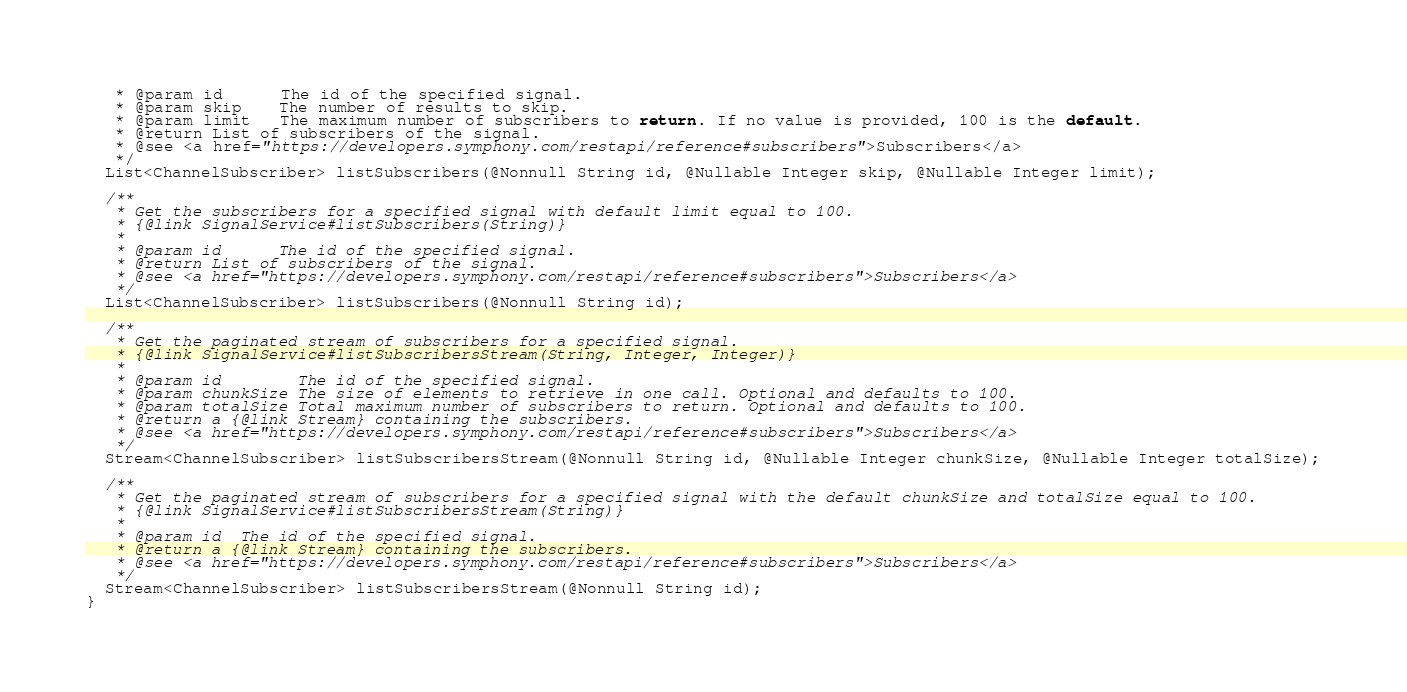<code> <loc_0><loc_0><loc_500><loc_500><_Java_>   * @param id      The id of the specified signal.
   * @param skip    The number of results to skip.
   * @param limit   The maximum number of subscribers to return. If no value is provided, 100 is the default.
   * @return List of subscribers of the signal.
   * @see <a href="https://developers.symphony.com/restapi/reference#subscribers">Subscribers</a>
   */
  List<ChannelSubscriber> listSubscribers(@Nonnull String id, @Nullable Integer skip, @Nullable Integer limit);

  /**
   * Get the subscribers for a specified signal with default limit equal to 100.
   * {@link SignalService#listSubscribers(String)}
   *
   * @param id      The id of the specified signal.
   * @return List of subscribers of the signal.
   * @see <a href="https://developers.symphony.com/restapi/reference#subscribers">Subscribers</a>
   */
  List<ChannelSubscriber> listSubscribers(@Nonnull String id);

  /**
   * Get the paginated stream of subscribers for a specified signal.
   * {@link SignalService#listSubscribersStream(String, Integer, Integer)}
   *
   * @param id        The id of the specified signal.
   * @param chunkSize The size of elements to retrieve in one call. Optional and defaults to 100.
   * @param totalSize Total maximum number of subscribers to return. Optional and defaults to 100.
   * @return a {@link Stream} containing the subscribers.
   * @see <a href="https://developers.symphony.com/restapi/reference#subscribers">Subscribers</a>
   */
  Stream<ChannelSubscriber> listSubscribersStream(@Nonnull String id, @Nullable Integer chunkSize, @Nullable Integer totalSize);

  /**
   * Get the paginated stream of subscribers for a specified signal with the default chunkSize and totalSize equal to 100.
   * {@link SignalService#listSubscribersStream(String)}
   *
   * @param id  The id of the specified signal.
   * @return a {@link Stream} containing the subscribers.
   * @see <a href="https://developers.symphony.com/restapi/reference#subscribers">Subscribers</a>
   */
  Stream<ChannelSubscriber> listSubscribersStream(@Nonnull String id);
}
</code> 